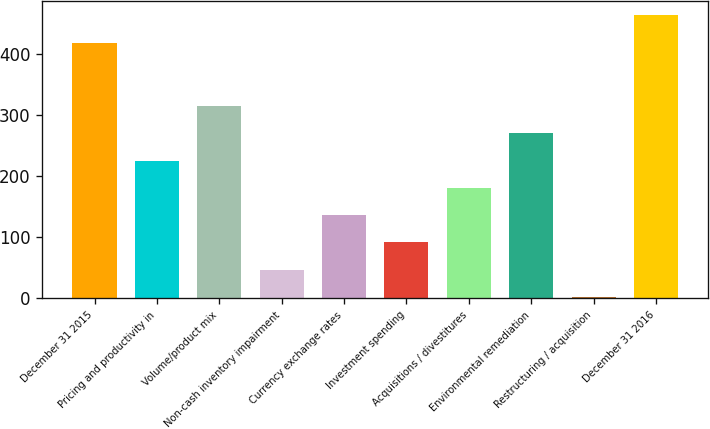<chart> <loc_0><loc_0><loc_500><loc_500><bar_chart><fcel>December 31 2015<fcel>Pricing and productivity in<fcel>Volume/product mix<fcel>Non-cash inventory impairment<fcel>Currency exchange rates<fcel>Investment spending<fcel>Acquisitions / divestitures<fcel>Environmental remediation<fcel>Restructuring / acquisition<fcel>December 31 2016<nl><fcel>418<fcel>225<fcel>314.24<fcel>46.52<fcel>135.76<fcel>91.14<fcel>180.38<fcel>269.62<fcel>1.9<fcel>462.62<nl></chart> 